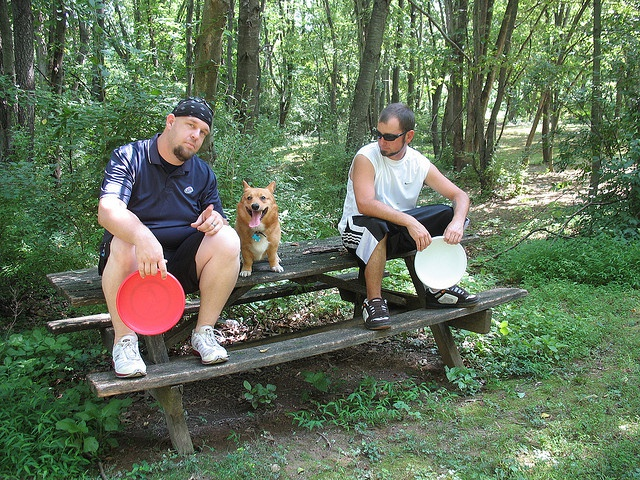Describe the objects in this image and their specific colors. I can see bench in black, gray, darkgray, and darkgreen tones, people in black, tan, white, and navy tones, people in black, lightgray, tan, and gray tones, frisbee in black, salmon, and red tones, and dog in black, maroon, gray, and tan tones in this image. 